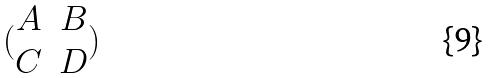Convert formula to latex. <formula><loc_0><loc_0><loc_500><loc_500>( \begin{matrix} A & B \\ C & D \end{matrix} )</formula> 